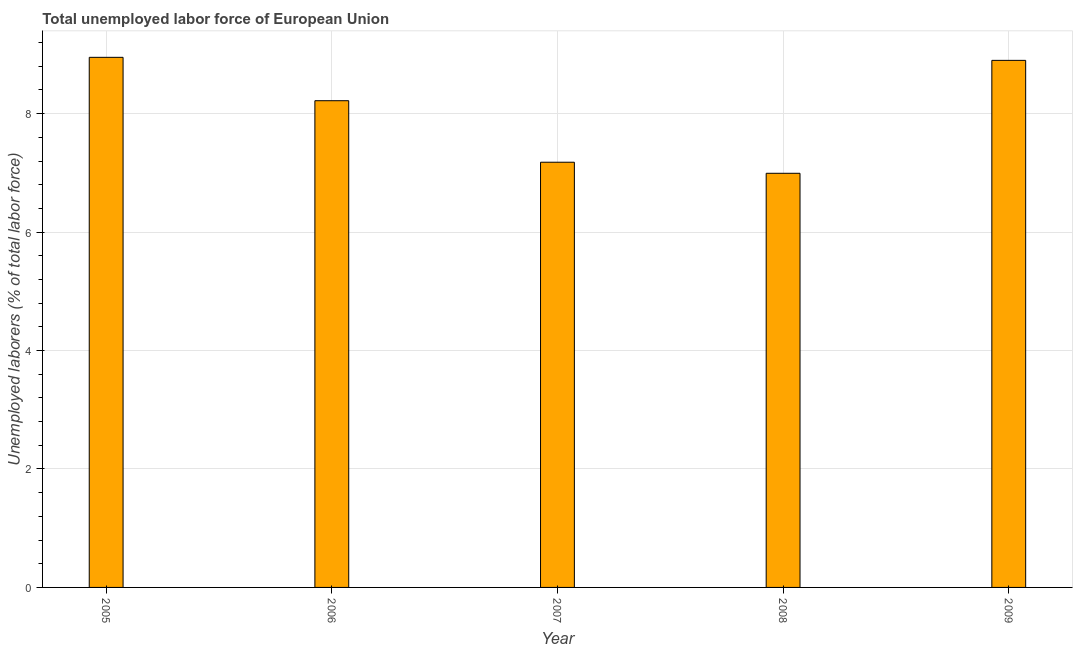Does the graph contain grids?
Provide a short and direct response. Yes. What is the title of the graph?
Offer a terse response. Total unemployed labor force of European Union. What is the label or title of the Y-axis?
Offer a terse response. Unemployed laborers (% of total labor force). What is the total unemployed labour force in 2006?
Keep it short and to the point. 8.22. Across all years, what is the maximum total unemployed labour force?
Your answer should be compact. 8.95. Across all years, what is the minimum total unemployed labour force?
Provide a short and direct response. 6.99. In which year was the total unemployed labour force maximum?
Ensure brevity in your answer.  2005. In which year was the total unemployed labour force minimum?
Make the answer very short. 2008. What is the sum of the total unemployed labour force?
Your response must be concise. 40.24. What is the difference between the total unemployed labour force in 2008 and 2009?
Give a very brief answer. -1.91. What is the average total unemployed labour force per year?
Your response must be concise. 8.05. What is the median total unemployed labour force?
Your answer should be very brief. 8.22. What is the ratio of the total unemployed labour force in 2006 to that in 2009?
Keep it short and to the point. 0.92. Is the difference between the total unemployed labour force in 2007 and 2009 greater than the difference between any two years?
Offer a terse response. No. What is the difference between the highest and the second highest total unemployed labour force?
Ensure brevity in your answer.  0.05. Is the sum of the total unemployed labour force in 2005 and 2007 greater than the maximum total unemployed labour force across all years?
Your answer should be compact. Yes. What is the difference between the highest and the lowest total unemployed labour force?
Your answer should be very brief. 1.96. How many bars are there?
Your response must be concise. 5. Are all the bars in the graph horizontal?
Make the answer very short. No. How many years are there in the graph?
Give a very brief answer. 5. What is the difference between two consecutive major ticks on the Y-axis?
Ensure brevity in your answer.  2. Are the values on the major ticks of Y-axis written in scientific E-notation?
Your answer should be very brief. No. What is the Unemployed laborers (% of total labor force) in 2005?
Your answer should be compact. 8.95. What is the Unemployed laborers (% of total labor force) in 2006?
Provide a short and direct response. 8.22. What is the Unemployed laborers (% of total labor force) in 2007?
Provide a short and direct response. 7.18. What is the Unemployed laborers (% of total labor force) in 2008?
Give a very brief answer. 6.99. What is the Unemployed laborers (% of total labor force) of 2009?
Give a very brief answer. 8.9. What is the difference between the Unemployed laborers (% of total labor force) in 2005 and 2006?
Give a very brief answer. 0.73. What is the difference between the Unemployed laborers (% of total labor force) in 2005 and 2007?
Ensure brevity in your answer.  1.77. What is the difference between the Unemployed laborers (% of total labor force) in 2005 and 2008?
Provide a short and direct response. 1.96. What is the difference between the Unemployed laborers (% of total labor force) in 2005 and 2009?
Provide a short and direct response. 0.05. What is the difference between the Unemployed laborers (% of total labor force) in 2006 and 2007?
Your answer should be very brief. 1.04. What is the difference between the Unemployed laborers (% of total labor force) in 2006 and 2008?
Ensure brevity in your answer.  1.23. What is the difference between the Unemployed laborers (% of total labor force) in 2006 and 2009?
Your answer should be compact. -0.68. What is the difference between the Unemployed laborers (% of total labor force) in 2007 and 2008?
Provide a succinct answer. 0.19. What is the difference between the Unemployed laborers (% of total labor force) in 2007 and 2009?
Your answer should be very brief. -1.72. What is the difference between the Unemployed laborers (% of total labor force) in 2008 and 2009?
Give a very brief answer. -1.91. What is the ratio of the Unemployed laborers (% of total labor force) in 2005 to that in 2006?
Offer a terse response. 1.09. What is the ratio of the Unemployed laborers (% of total labor force) in 2005 to that in 2007?
Make the answer very short. 1.25. What is the ratio of the Unemployed laborers (% of total labor force) in 2005 to that in 2008?
Give a very brief answer. 1.28. What is the ratio of the Unemployed laborers (% of total labor force) in 2005 to that in 2009?
Offer a terse response. 1.01. What is the ratio of the Unemployed laborers (% of total labor force) in 2006 to that in 2007?
Provide a short and direct response. 1.15. What is the ratio of the Unemployed laborers (% of total labor force) in 2006 to that in 2008?
Your answer should be compact. 1.18. What is the ratio of the Unemployed laborers (% of total labor force) in 2006 to that in 2009?
Your response must be concise. 0.92. What is the ratio of the Unemployed laborers (% of total labor force) in 2007 to that in 2009?
Offer a very short reply. 0.81. What is the ratio of the Unemployed laborers (% of total labor force) in 2008 to that in 2009?
Offer a very short reply. 0.79. 